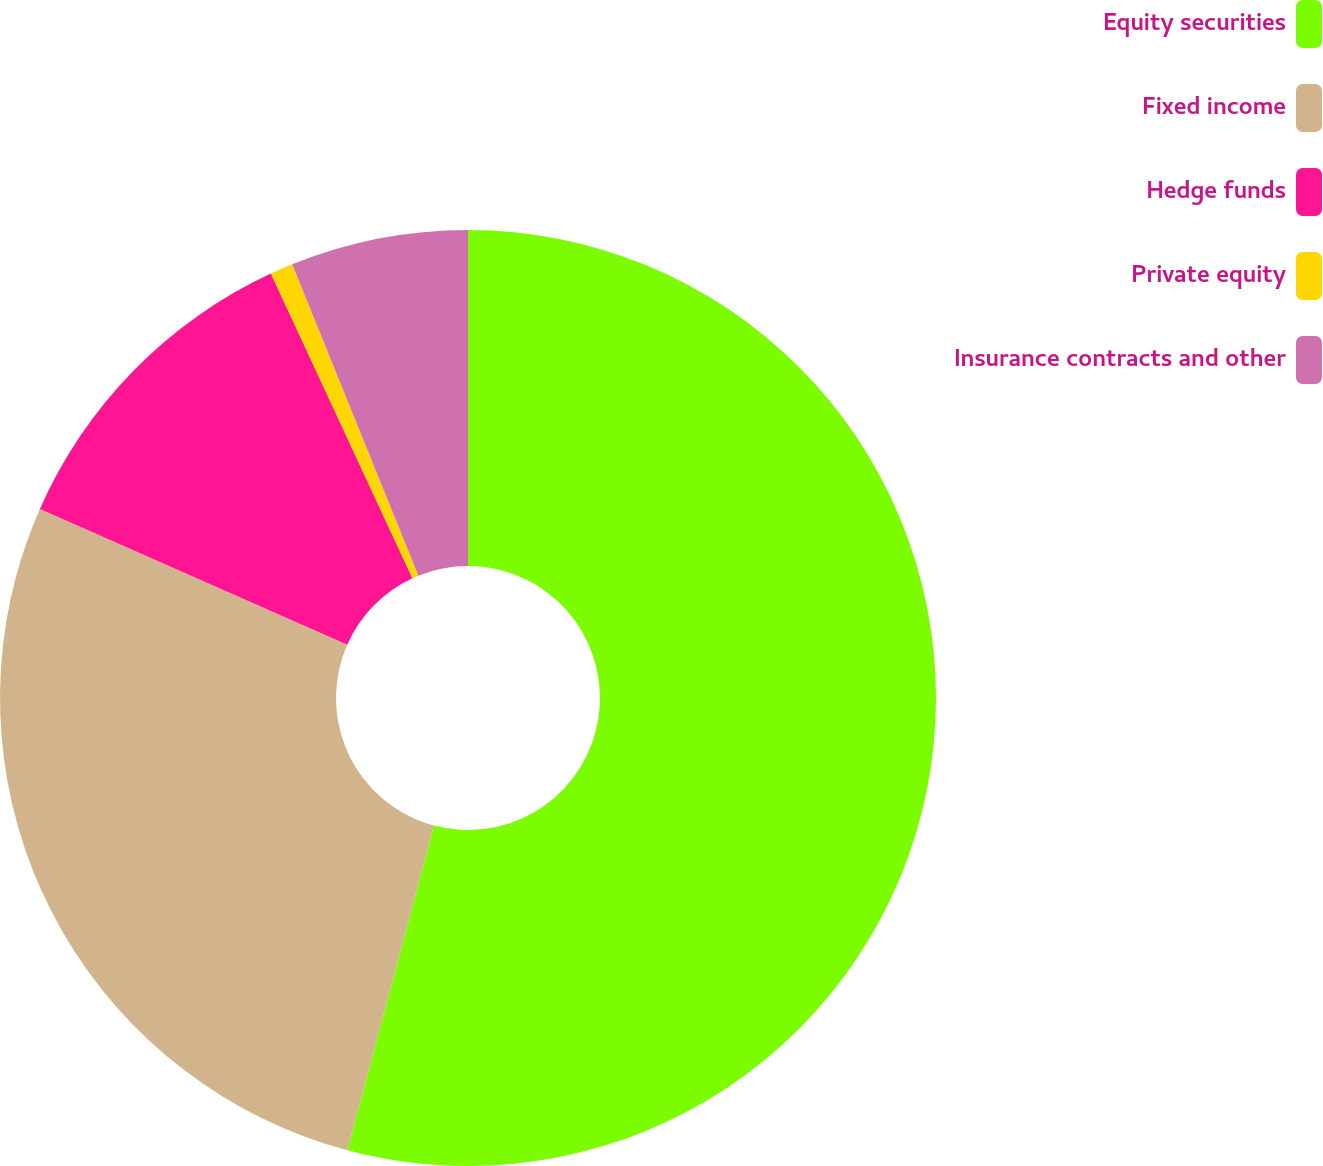Convert chart. <chart><loc_0><loc_0><loc_500><loc_500><pie_chart><fcel>Equity securities<fcel>Fixed income<fcel>Hedge funds<fcel>Private equity<fcel>Insurance contracts and other<nl><fcel>54.15%<fcel>27.47%<fcel>11.46%<fcel>0.79%<fcel>6.13%<nl></chart> 